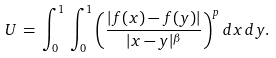<formula> <loc_0><loc_0><loc_500><loc_500>U \, = \, \int _ { 0 } ^ { 1 } \, \int _ { 0 } ^ { 1 } \left ( \frac { | f ( x ) - f ( y ) | } { | x - y | ^ { \beta } } \right ) ^ { p } d x \, d y .</formula> 